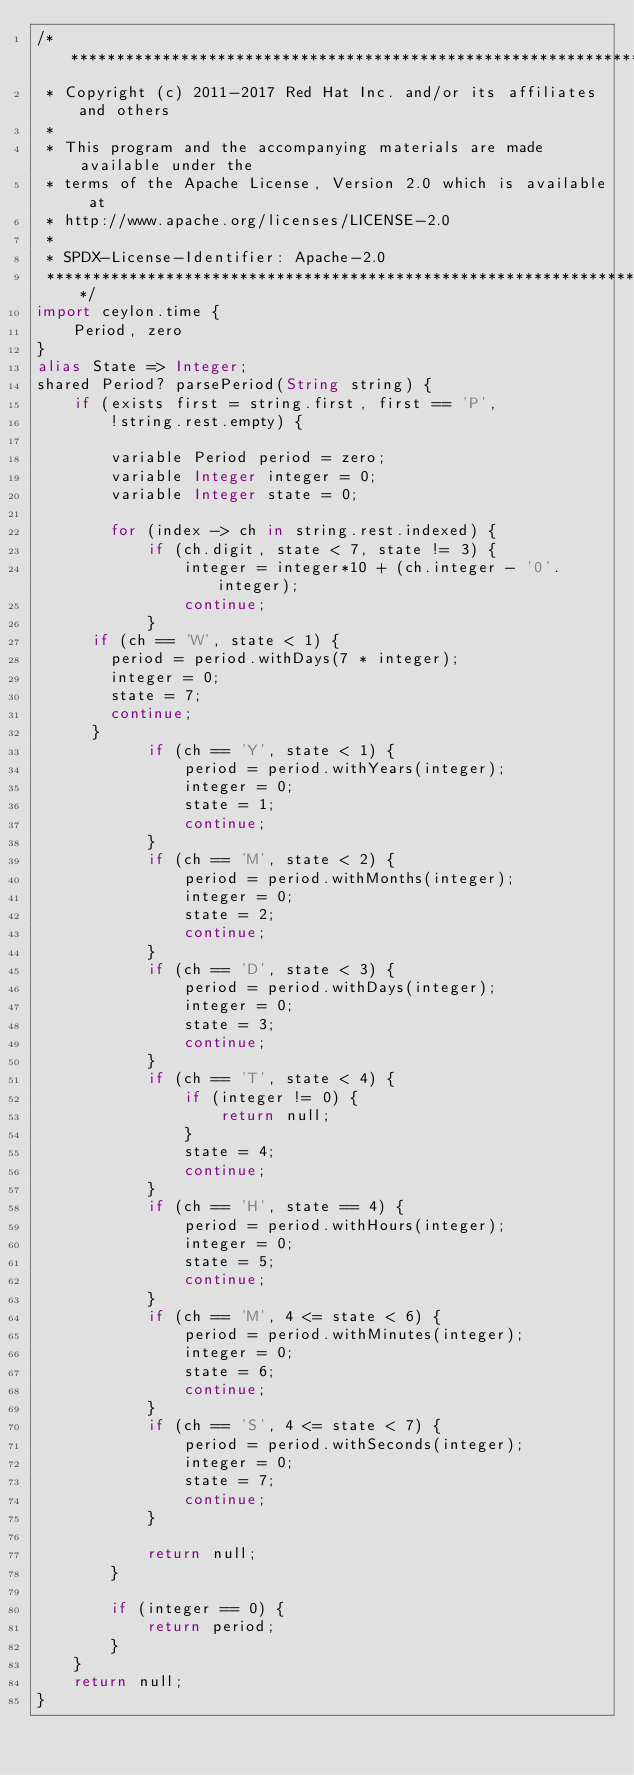<code> <loc_0><loc_0><loc_500><loc_500><_Ceylon_>/********************************************************************************
 * Copyright (c) 2011-2017 Red Hat Inc. and/or its affiliates and others
 *
 * This program and the accompanying materials are made available under the 
 * terms of the Apache License, Version 2.0 which is available at
 * http://www.apache.org/licenses/LICENSE-2.0
 *
 * SPDX-License-Identifier: Apache-2.0 
 ********************************************************************************/
import ceylon.time {
    Period, zero
}
alias State => Integer;
shared Period? parsePeriod(String string) {
    if (exists first = string.first, first == 'P',
        !string.rest.empty) {
        
        variable Period period = zero;
        variable Integer integer = 0;
        variable Integer state = 0;
        
        for (index -> ch in string.rest.indexed) {
            if (ch.digit, state < 7, state != 3) {
                integer = integer*10 + (ch.integer - '0'.integer);
                continue;
            }
			if (ch == 'W', state < 1) {
				period = period.withDays(7 * integer);
				integer = 0;
				state = 7;
				continue;
			}
            if (ch == 'Y', state < 1) {
                period = period.withYears(integer);
                integer = 0;
                state = 1;
                continue;
            }
            if (ch == 'M', state < 2) {
                period = period.withMonths(integer);
                integer = 0;
                state = 2;
                continue;
            }
            if (ch == 'D', state < 3) {
                period = period.withDays(integer);
                integer = 0;
                state = 3;
                continue;
            }
            if (ch == 'T', state < 4) {
                if (integer != 0) {
                    return null;
                }
                state = 4;
                continue;
            }
            if (ch == 'H', state == 4) {
                period = period.withHours(integer);
                integer = 0;
                state = 5;
                continue;
            }
            if (ch == 'M', 4 <= state < 6) {
                period = period.withMinutes(integer);
                integer = 0;
                state = 6;
                continue;
            }
            if (ch == 'S', 4 <= state < 7) {
                period = period.withSeconds(integer);
                integer = 0;
                state = 7;
                continue;
            }
            
            return null;
        }
        
        if (integer == 0) {
            return period;
        }
    }
    return null;
}
</code> 